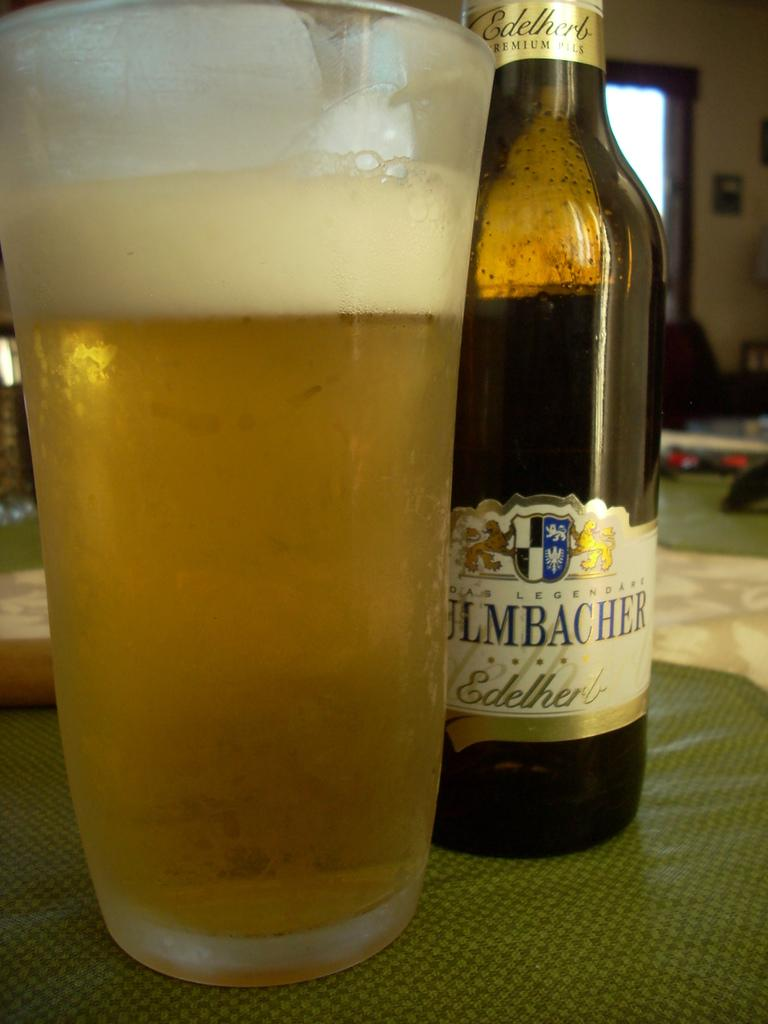<image>
Give a short and clear explanation of the subsequent image. the half leveled edelherb premium pills bottle which placed back to the glass of beer 